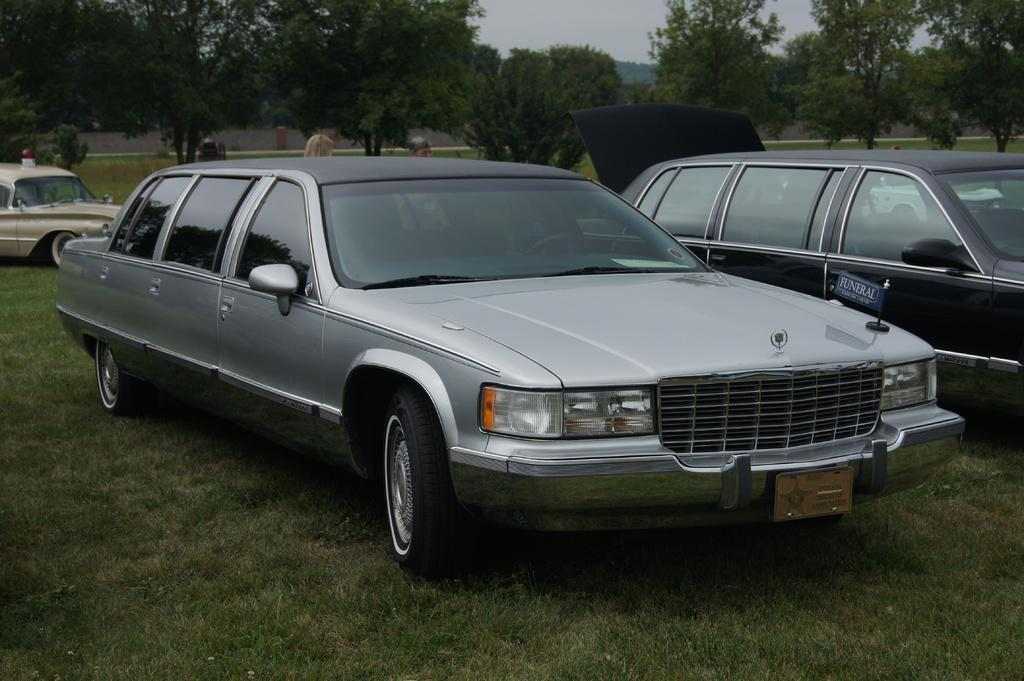What type of vehicles can be seen in the image? There are cars in the image. What natural elements are visible in the image? Trees and grass are visible in the image. What is the condition of the car's trunk in the image? The car's trunk is opened in the image. What is the weather like in the image? The sky is cloudy in the image. What type of reward can be seen on the beds in the image? There are no beds present in the image, so there is no reward to be seen. 